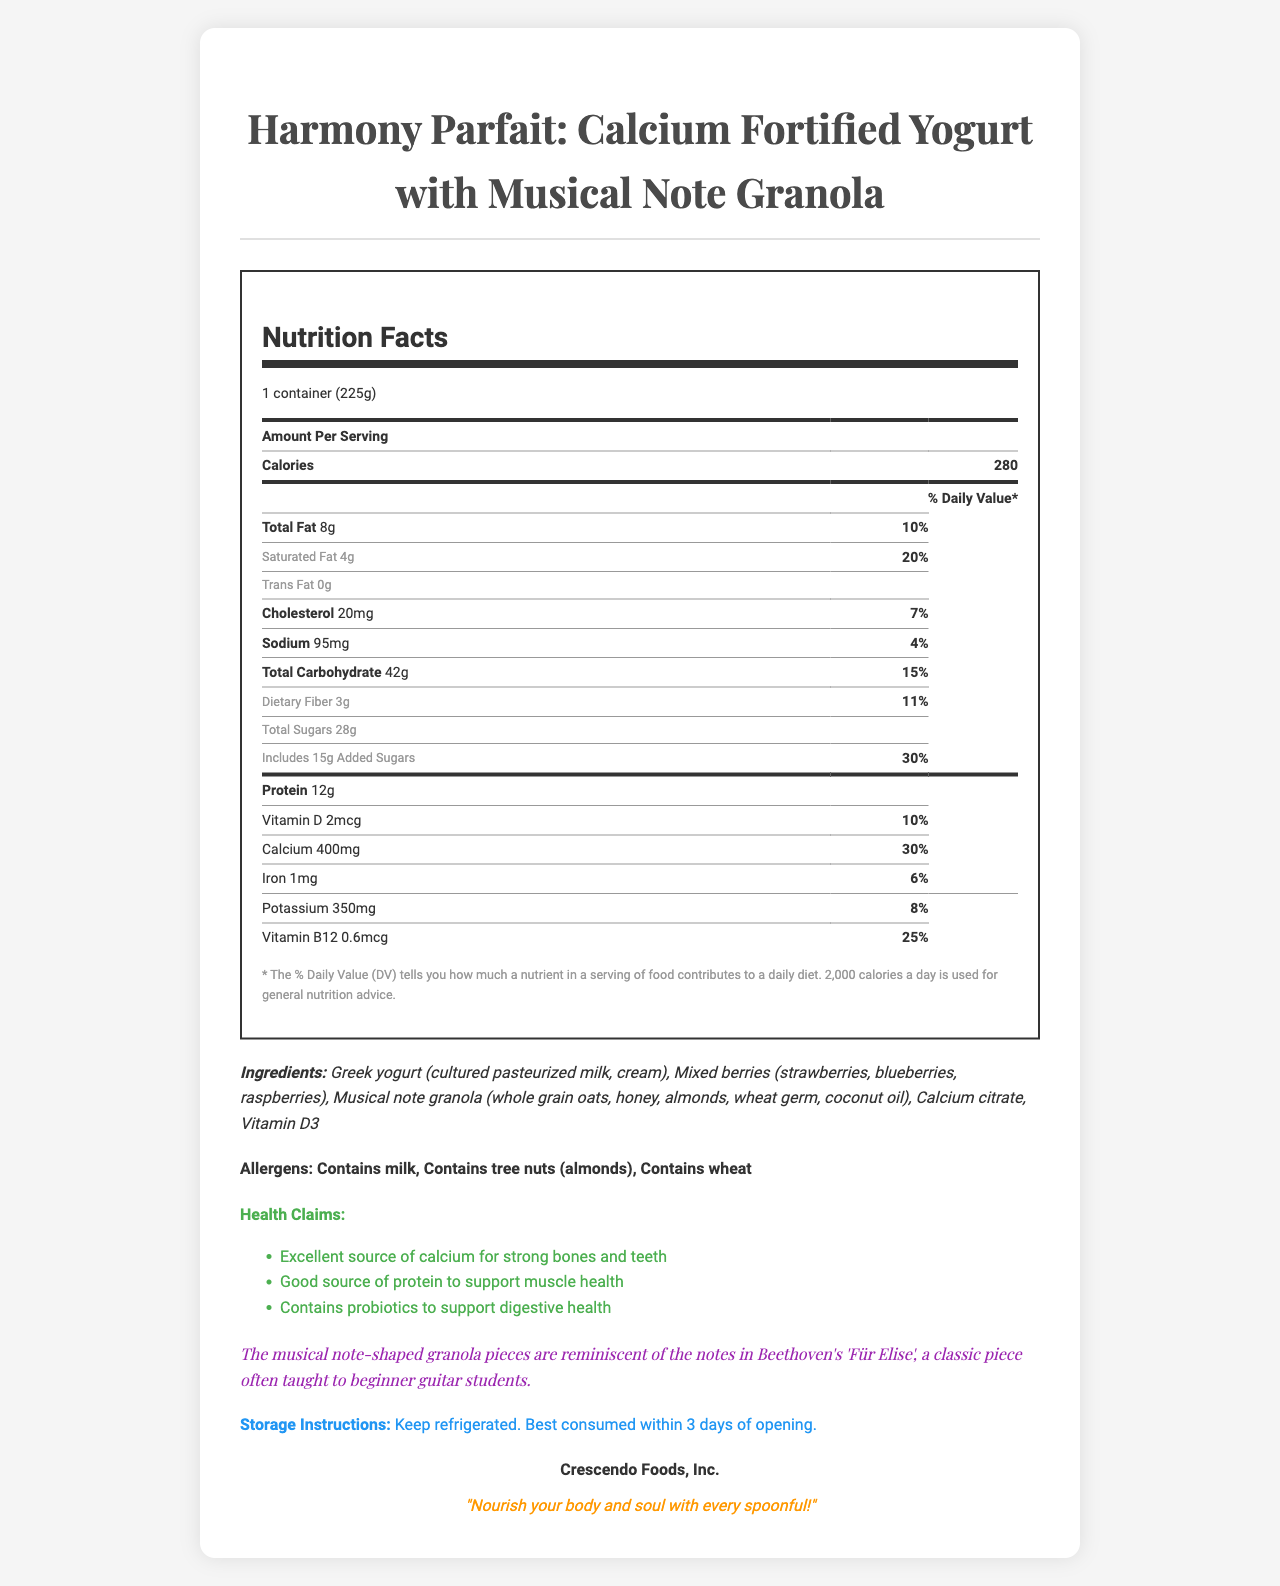what is the serving size? The serving size is indicated at the top of the nutrition facts, listed as "1 container (225g)".
Answer: 1 container (225g) how many calories are in one serving? The document specifies that one serving contains 280 calories.
Answer: 280 how much total fat is in one serving, and what is its daily value percentage? The nutrition facts label lists total fat as 8g and its daily value percentage as 10%.
Answer: 8g, 10% how much calcium does the product contain, and what percentage of the daily value does this represent? The label states that the product contains 400mg of calcium, which is 30% of the daily value.
Answer: 400mg, 30% what are the main ingredients of the product? These ingredients are listed at the bottom of the document under the "Ingredients" section.
Answer: Greek yogurt, mixed berries, musical note granola, calcium citrate, vitamin D3 what health claims are associated with this product? These claims are mentioned in the "Health Claims" section of the document.
Answer: Excellent source of calcium for strong bones and teeth, good source of protein to support muscle health, contains probiotics to support digestive health how is the musical inspiration for the product described? This description is found in the "Musical Inspiration" section of the document.
Answer: The musical note-shaped granola pieces are reminiscent of the notes in Beethoven's 'Für Elise' which company manufactures the product? The manufacturer is listed at the bottom of the document.
Answer: Crescendo Foods, Inc. what should be the storage conditions for this product? The storage conditions are stated in the "Storage Instructions" section.
Answer: Keep refrigerated. Best consumed within 3 days of opening. which of the following allergens are contained in the product? A. Milk B. Almonds C. Wheat D. All of the above The Allergens section lists milk, tree nuts (almonds), and wheat as allergens, making "All of the above" the correct answer.
Answer: D. All of the above how much protein is in one serving? A. 8g B. 10g C. 12g D. 14g The nutrition facts specify that one serving contains 12g of protein.
Answer: C. 12g is this product fortified with vitamin B12? The nutrition facts label includes vitamin B12 with an amount of 0.6mcg and a daily value of 25%.
Answer: Yes Summarize the main idea of the document. The document contains various sections detailing the nutritional facts, ingredients, allergens, health claims, and the unique design inspiration related to the product.
Answer: The document provides detailed information about the Harmony Parfait, a calcium-fortified yogurt with musical note-shaped granola. It highlights the nutritional content, health benefits, ingredients, allergens, and the musical inspiration behind the product, manufactured by Crescendo Foods. can I find out where the product was sourced or manufactured from within this document? The document does not provide specific details about the sourcing or manufacturing location beyond mentioning the manufacturer's name, Crescendo Foods, Inc.
Answer: Not enough information 